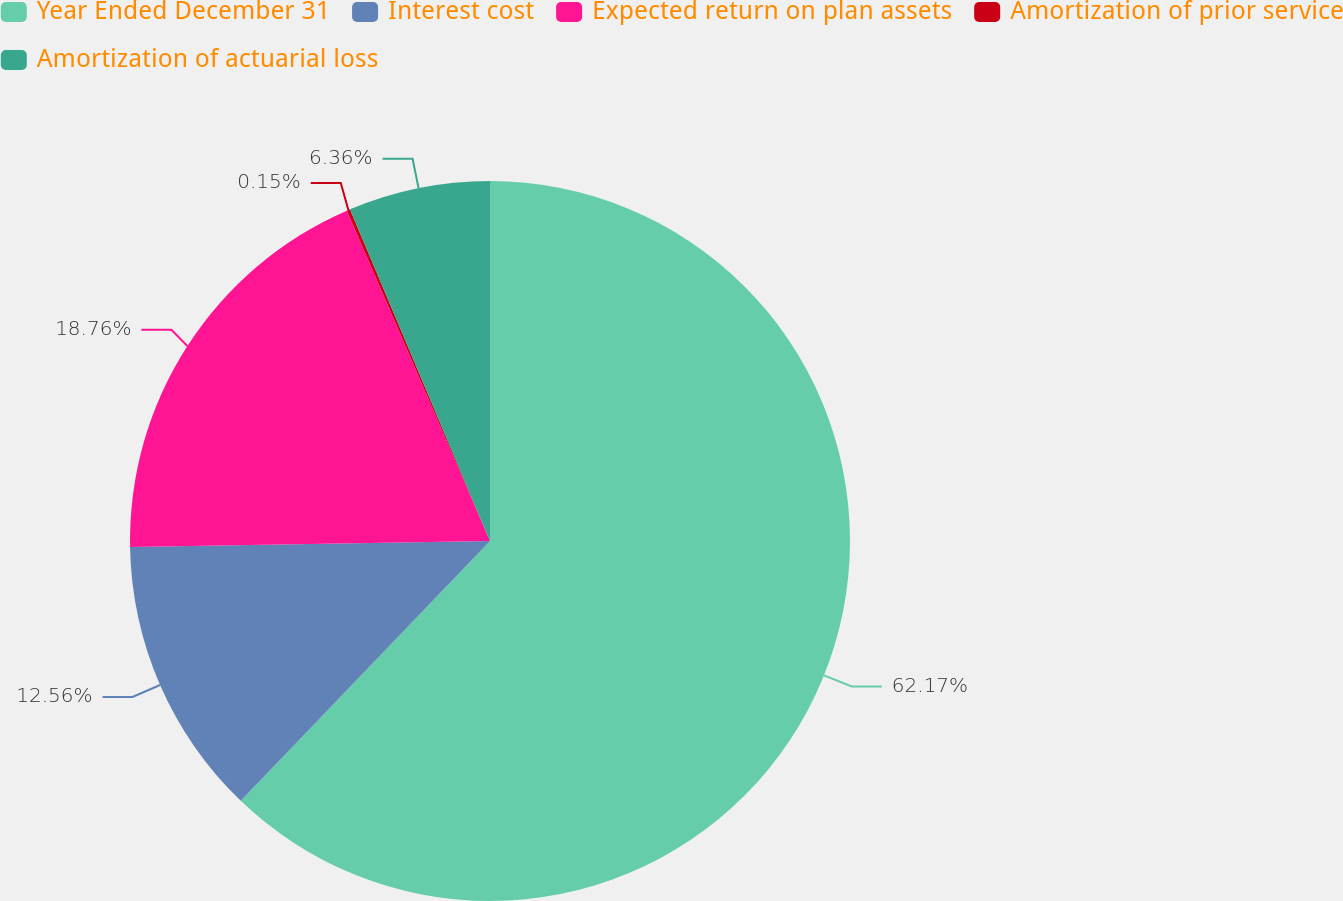Convert chart. <chart><loc_0><loc_0><loc_500><loc_500><pie_chart><fcel>Year Ended December 31<fcel>Interest cost<fcel>Expected return on plan assets<fcel>Amortization of prior service<fcel>Amortization of actuarial loss<nl><fcel>62.17%<fcel>12.56%<fcel>18.76%<fcel>0.15%<fcel>6.36%<nl></chart> 